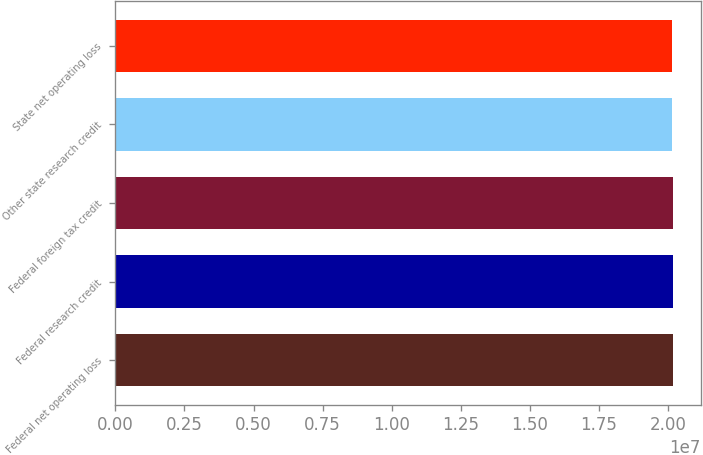Convert chart. <chart><loc_0><loc_0><loc_500><loc_500><bar_chart><fcel>Federal net operating loss<fcel>Federal research credit<fcel>Federal foreign tax credit<fcel>Other state research credit<fcel>State net operating loss<nl><fcel>2.0185e+07<fcel>2.0188e+07<fcel>2.0182e+07<fcel>2.0155e+07<fcel>2.0152e+07<nl></chart> 